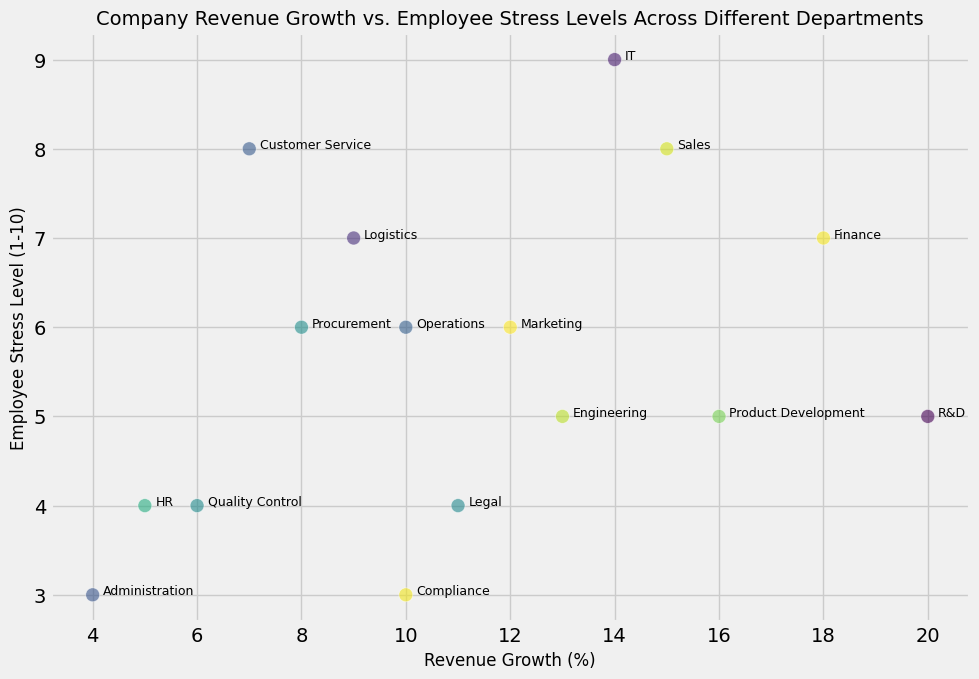Which department has the highest revenue growth? The department with the highest revenue growth is indicated by the highest point on the x-axis in the scatter plot. R&D shows the highest revenue growth at 20%.
Answer: R&D Which departments have a stress level below 5? To find this, look for scatter points below the y-axis value of 5. The departments identified are HR, Legal, Administration, Quality Control, Compliance, Product Development, and Engineering.
Answer: HR, Legal, Administration, Quality Control, Compliance, Product Development, Engineering What is the relationship between revenue growth and employee stress level in the IT department? Locate the IT department on the scatter plot; its coordinates are (14, 9). This indicates a high revenue growth of 14% and a high-stress level of 9.
Answer: Positive relationship (Both high) Which department has the lowest employee stress level, and what is its revenue growth? The lowest point on the y-axis indicates the lowest stress level. Administration has the lowest stress level at 3, with a revenue growth of 4%.
Answer: Administration, 4% What is the average revenue growth of departments with a stress level of 6? Departments with a stress level of 6 are Marketing, Operations, and Procurement. Their revenue growths are 12%, 10%, and 8%. The average is calculated as (12 + 10 + 8) / 3 = 10%.
Answer: 10% Which department has a higher stress level, Sales or Finance? Compare the y-axis values for Sales and Finance. Sales has a stress level of 8 and Finance has a stress level of 7. Sales has a higher stress level.
Answer: Sales Are there any departments with matching stress levels but different revenue growth? Look for departments sharing the same y-axis value. Sales and Customer Service both have a stress level of 8 but different revenue growths of 15% and 7%, respectively. Marketing, Operations, and Procurement all have a stress level of 6 but different revenue growths of 12%, 10%, and 8%. Legal, HR, Quality Control all have a stress level of 4 but different revenue growths of 11%, 5%, and 6%. Product Development, R&D, Engineering all have a stress level of 5 but different revenue growths of 16%, 20%, and 13%. Compliance and Administration have a stress level of 3 but different revenue growths of 10% and 4%.
Answer: Yes What is the combined revenue growth of departments with a stress level of 7? Identify departments with a stress level of 7: Finance and Logistics. Their revenue growths are 18% and 9%, respectively. The combined growth is 18 + 9 = 27%.
Answer: 27% Which department has the closest revenue growth to the average revenue growth of all departments? First, find the average revenue growth of all departments: (15 + 12 + 5 + 18 + 10 + 14 + 7 + 20 + 11 + 9 + 16 + 4 + 8 + 13 + 6 + 10) / 16 ≈ 11.31%. The closest department is Legal with a revenue growth of 11%.
Answer: Legal Is there a correlation between revenue growth and employee stress level? Looking at the scatter plot, there doesn't appear to be a strong, clear correlation between revenue growth and stress level as the points are scattered without a specific trend line. However, a more detailed statistical analysis would be required for confirmation.
Answer: No clear correlation 